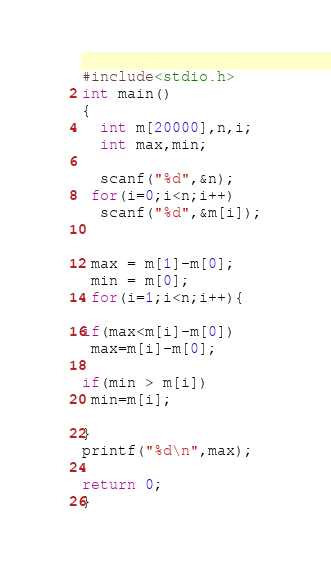<code> <loc_0><loc_0><loc_500><loc_500><_C_>#include<stdio.h>
int main()
{
  int m[20000],n,i;
  int max,min;

  scanf("%d",&n);
 for(i=0;i<n;i++)
  scanf("%d",&m[i]);


 max = m[1]-m[0];
 min = m[0];
 for(i=1;i<n;i++){

if(max<m[i]-m[0]) 
 max=m[i]-m[0];

if(min > m[i])
 min=m[i];

}
printf("%d\n",max);

return 0;
}</code> 